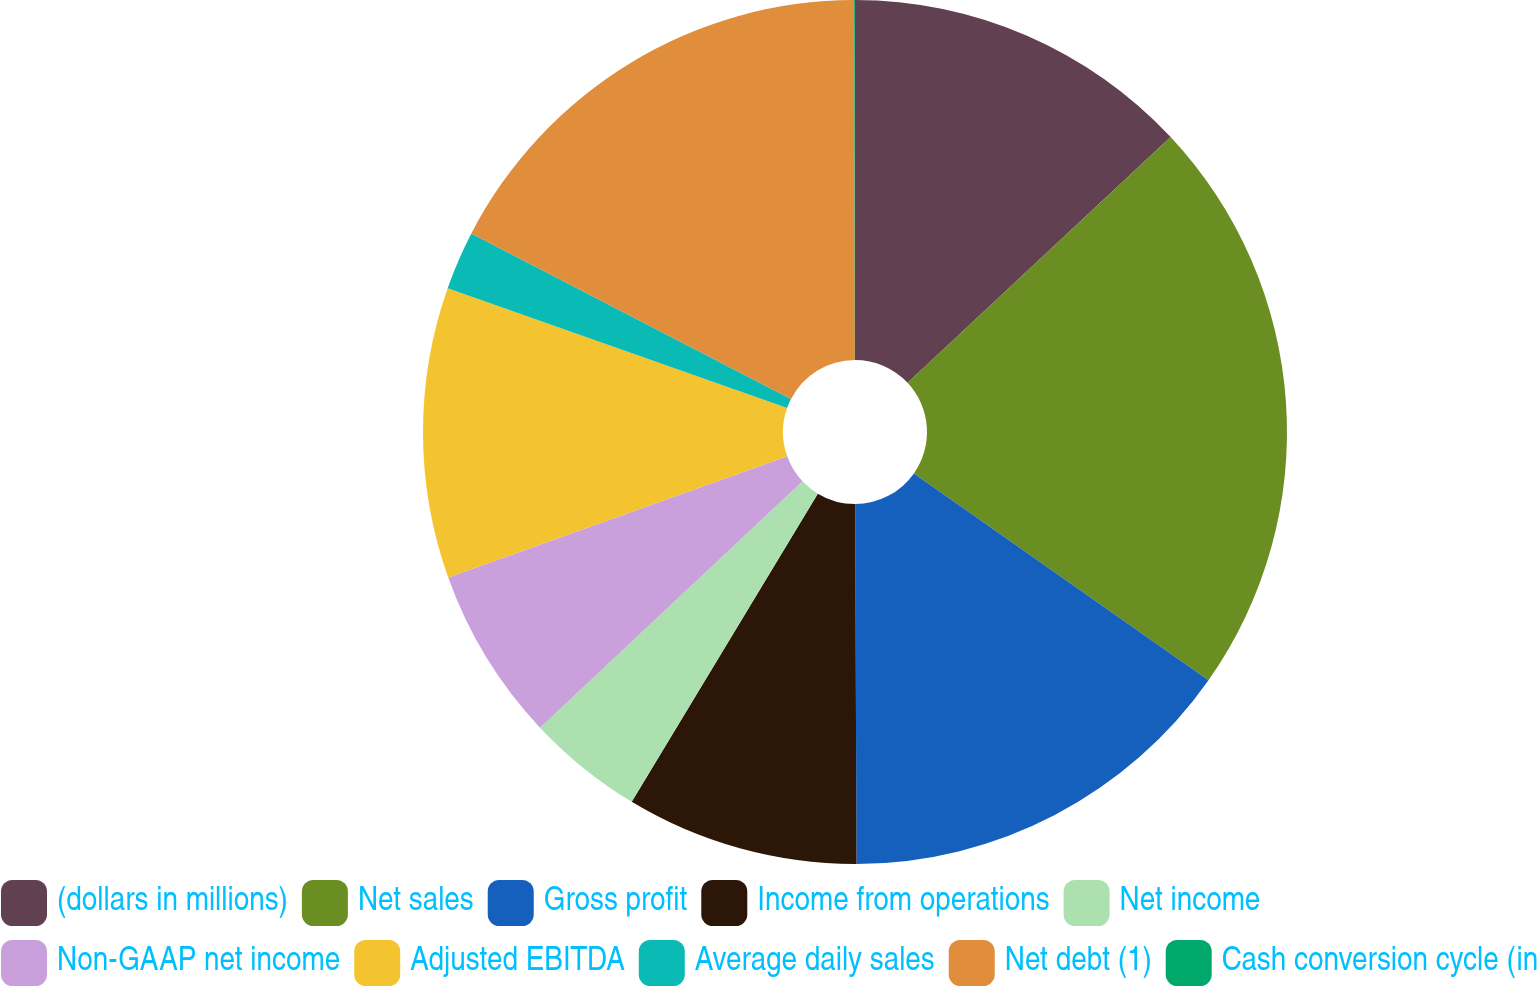<chart> <loc_0><loc_0><loc_500><loc_500><pie_chart><fcel>(dollars in millions)<fcel>Net sales<fcel>Gross profit<fcel>Income from operations<fcel>Net income<fcel>Non-GAAP net income<fcel>Adjusted EBITDA<fcel>Average daily sales<fcel>Net debt (1)<fcel>Cash conversion cycle (in<nl><fcel>13.04%<fcel>21.71%<fcel>15.2%<fcel>8.7%<fcel>4.36%<fcel>6.53%<fcel>10.87%<fcel>2.2%<fcel>17.37%<fcel>0.03%<nl></chart> 